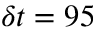Convert formula to latex. <formula><loc_0><loc_0><loc_500><loc_500>\delta t = 9 5</formula> 